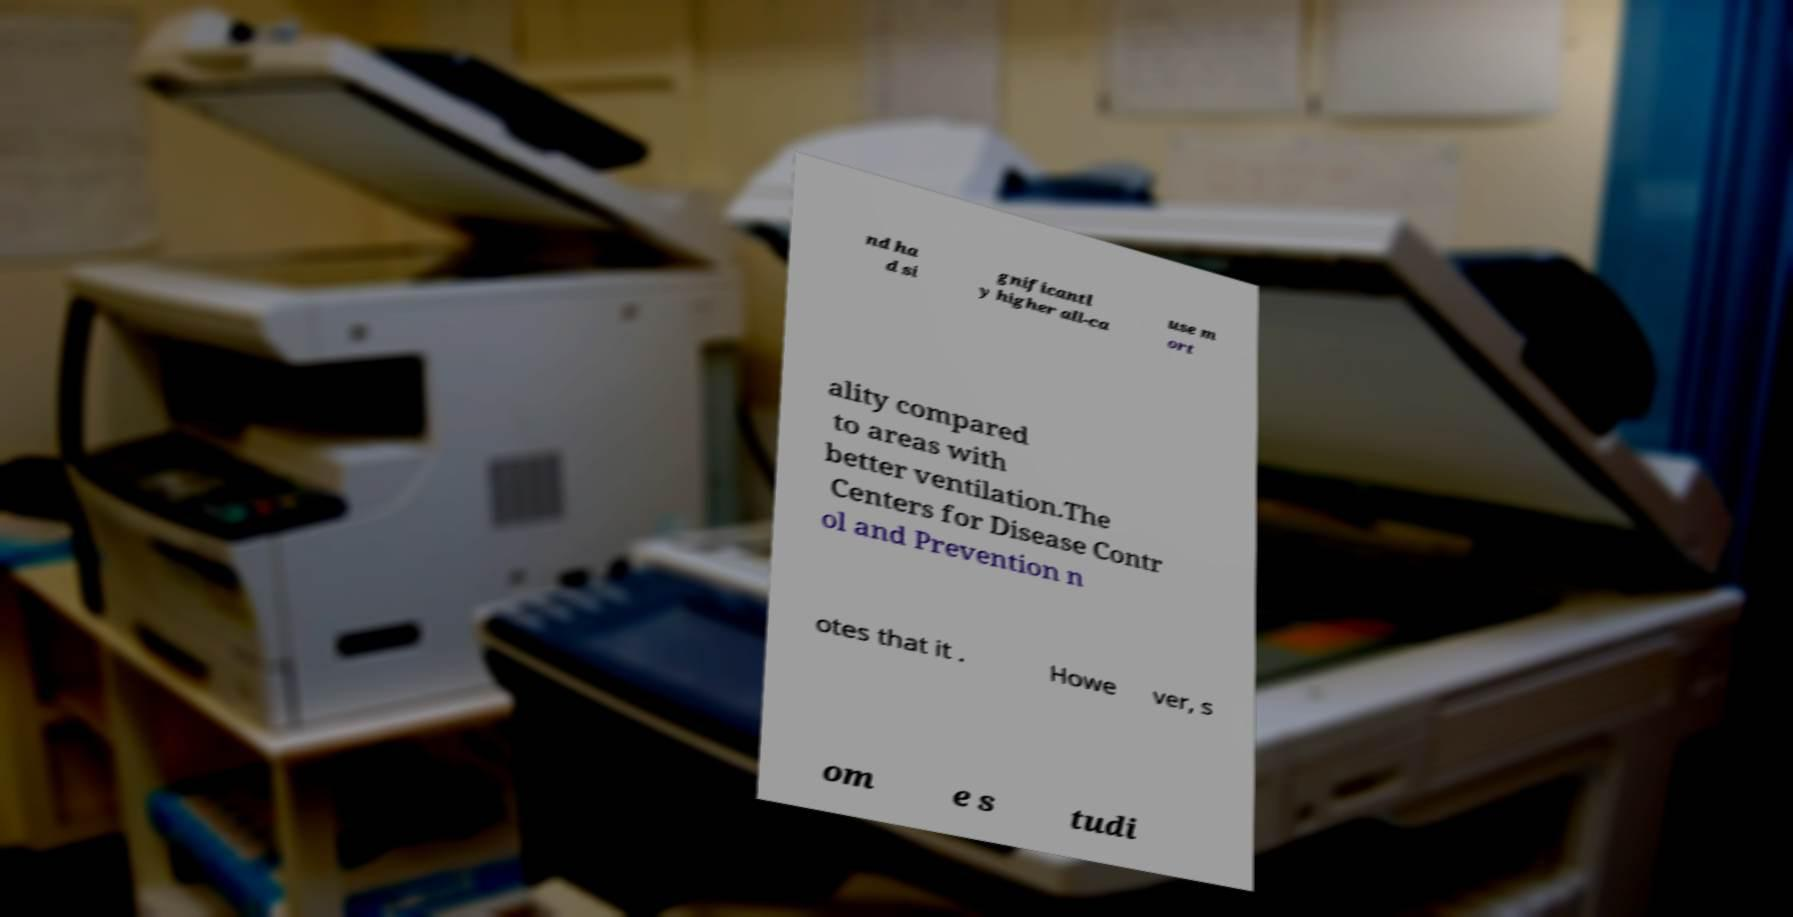Please read and relay the text visible in this image. What does it say? nd ha d si gnificantl y higher all-ca use m ort ality compared to areas with better ventilation.The Centers for Disease Contr ol and Prevention n otes that it . Howe ver, s om e s tudi 